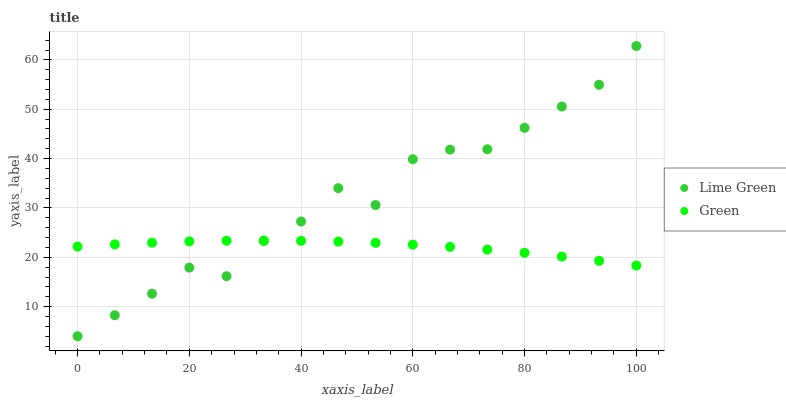Does Green have the minimum area under the curve?
Answer yes or no. Yes. Does Lime Green have the maximum area under the curve?
Answer yes or no. Yes. Does Lime Green have the minimum area under the curve?
Answer yes or no. No. Is Green the smoothest?
Answer yes or no. Yes. Is Lime Green the roughest?
Answer yes or no. Yes. Is Lime Green the smoothest?
Answer yes or no. No. Does Lime Green have the lowest value?
Answer yes or no. Yes. Does Lime Green have the highest value?
Answer yes or no. Yes. Does Green intersect Lime Green?
Answer yes or no. Yes. Is Green less than Lime Green?
Answer yes or no. No. Is Green greater than Lime Green?
Answer yes or no. No. 